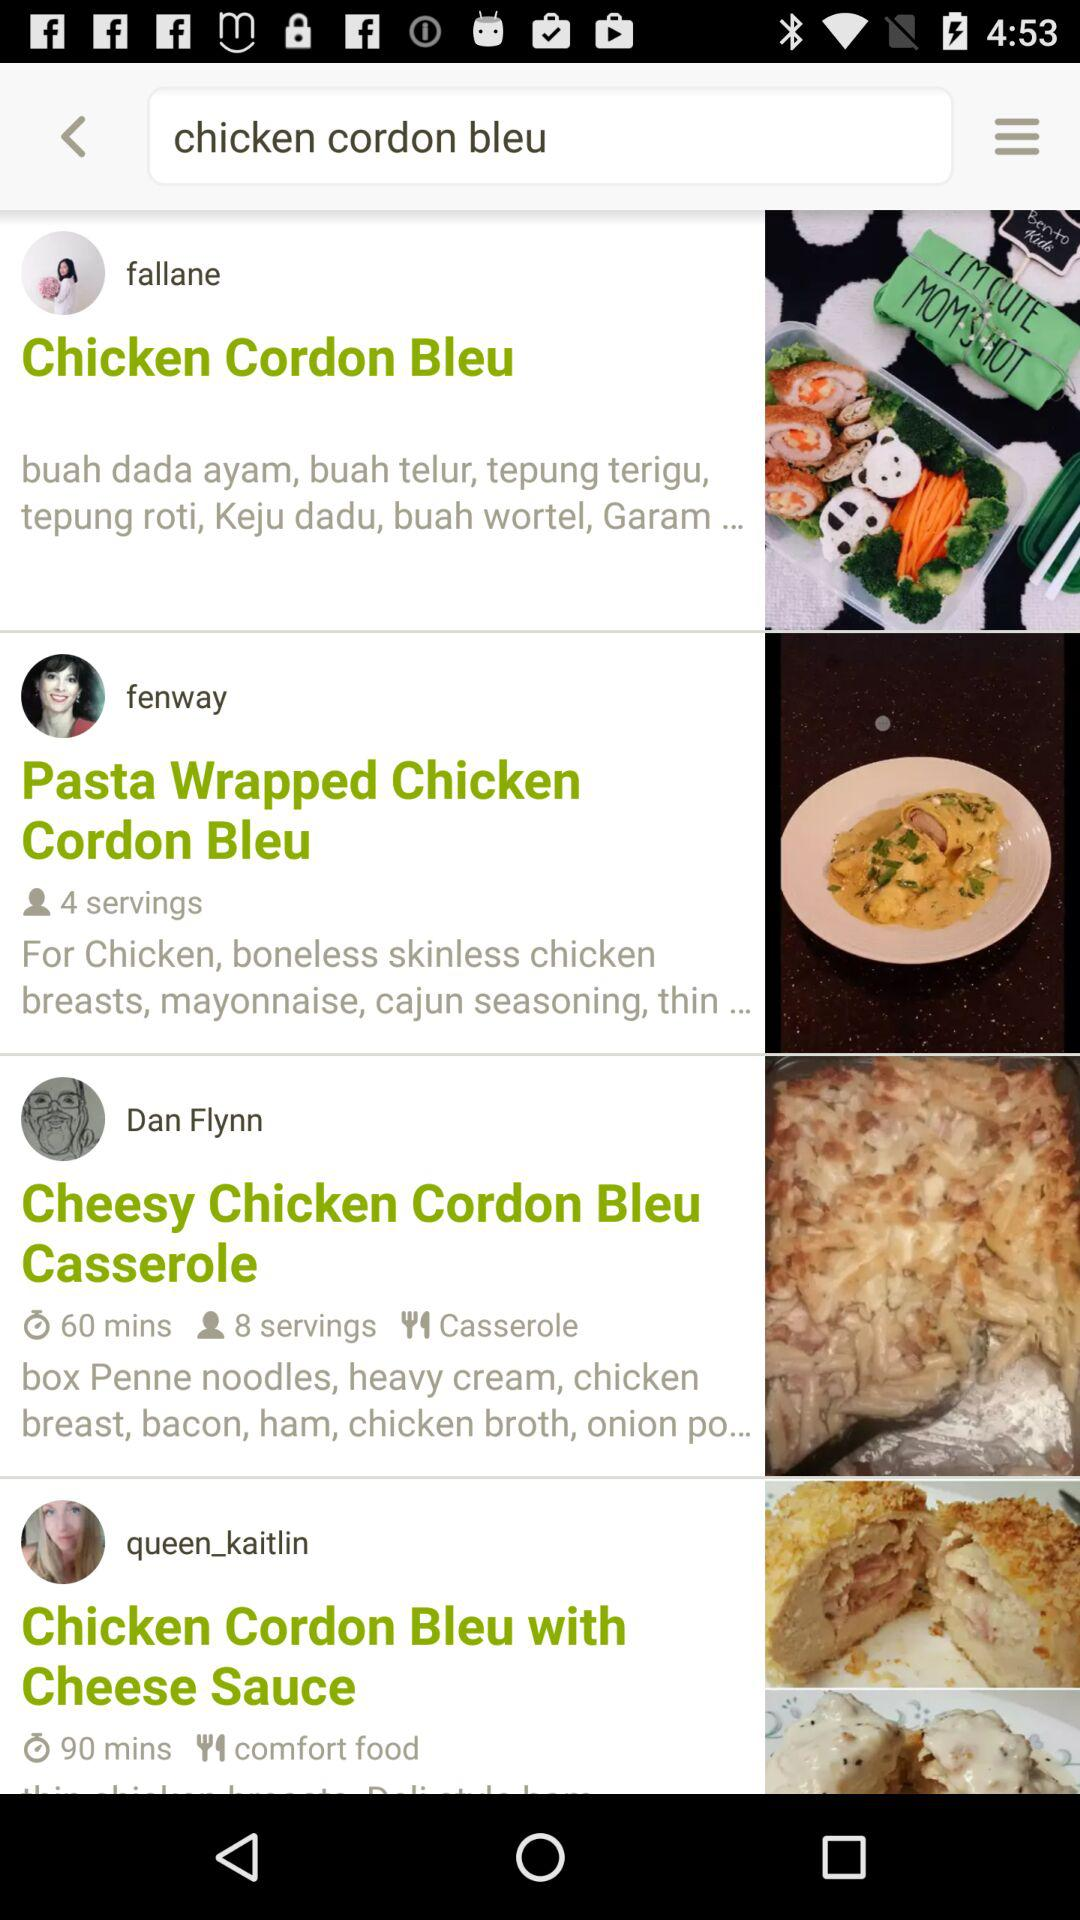How many servings does the recipe with the least number of servings have?
Answer the question using a single word or phrase. 4 